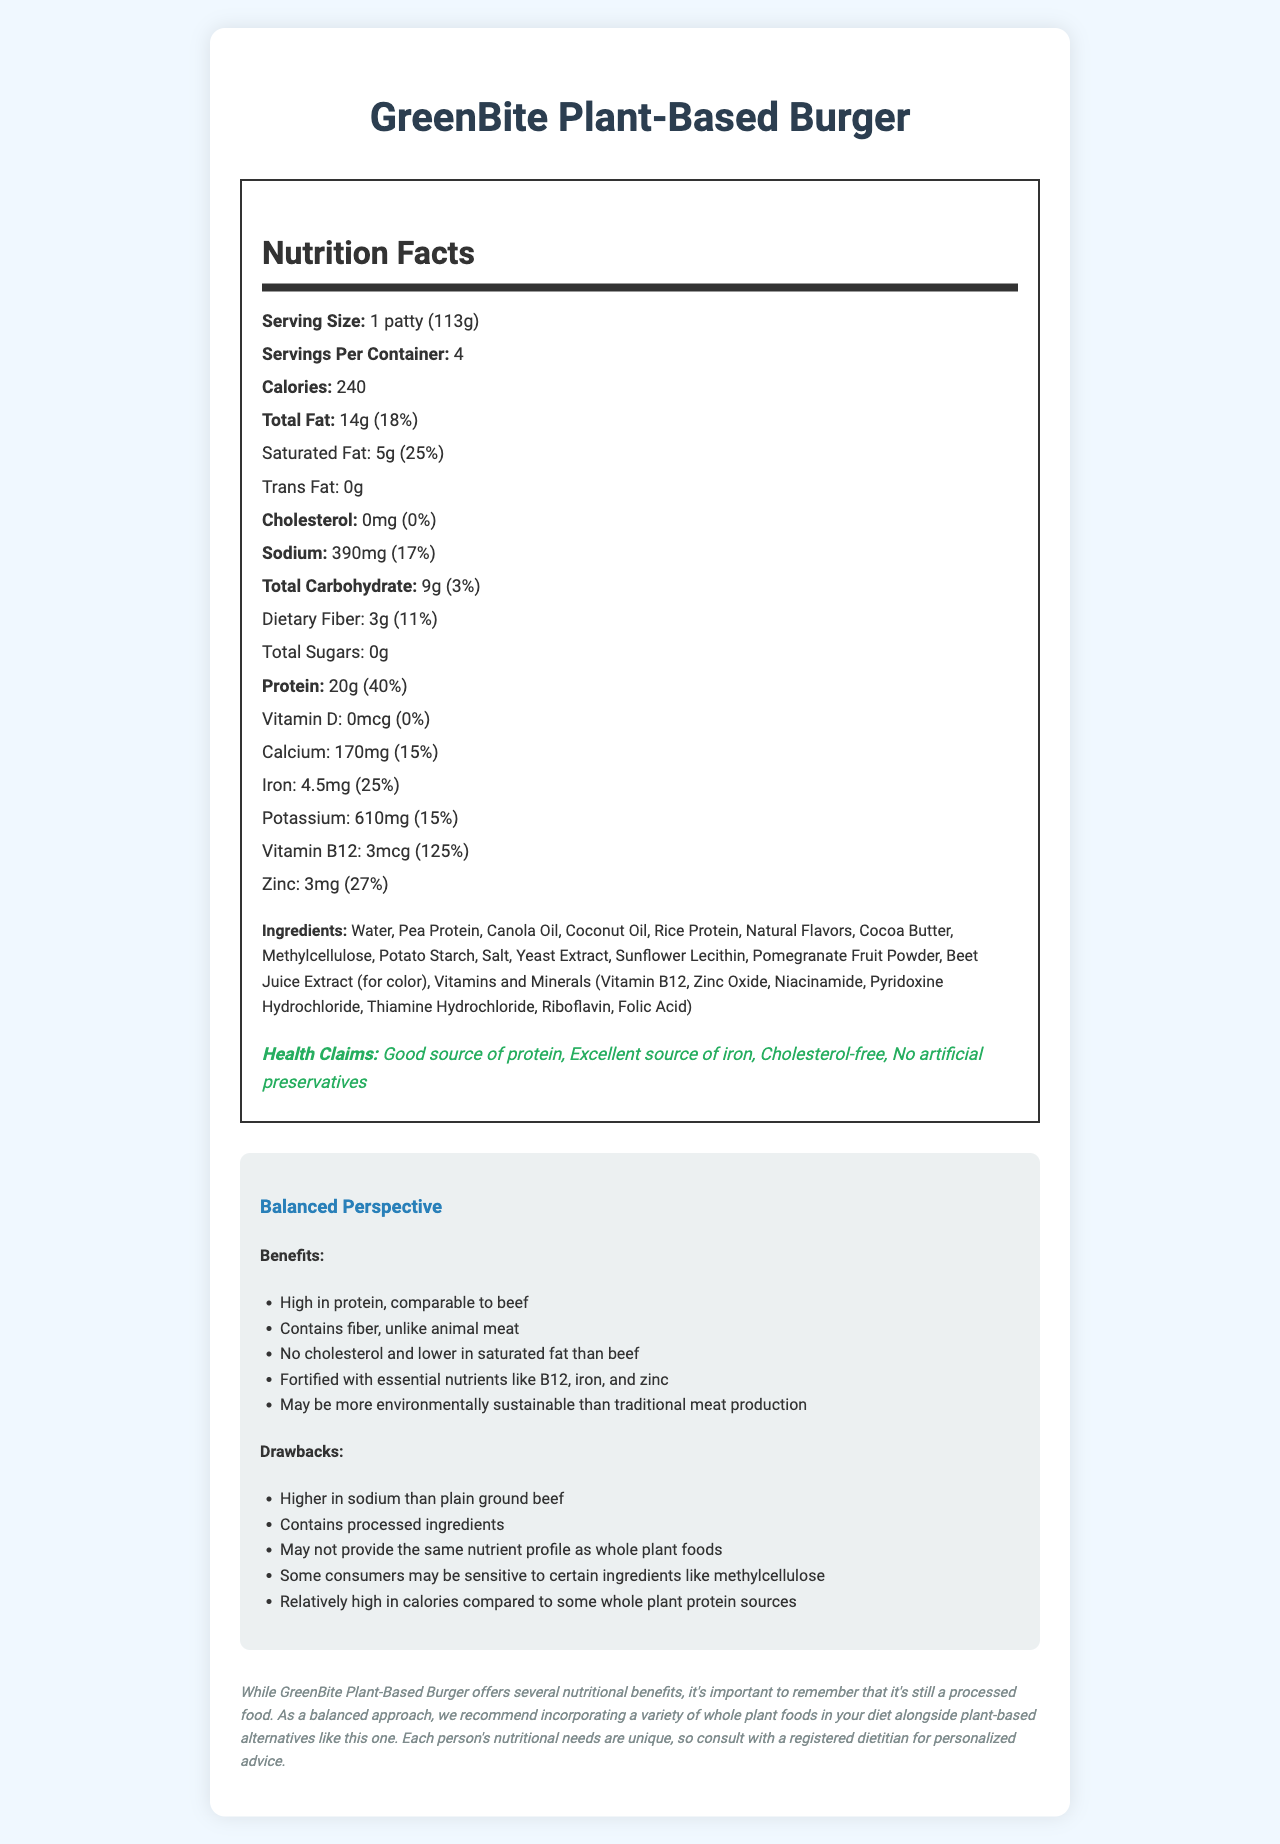what is the serving size for GreenBite Plant-Based Burger? The serving size is listed right below the product name and is specified as "1 patty (113g)."
Answer: 1 patty (113g) how many servings are there per container? The document indicates that there are 4 servings per container.
Answer: 4 how many grams of saturated fat are in one serving? Saturated fat is specified to be 5g per serving, found under the total fat section.
Answer: 5g what is the daily value percentage for protein per serving? The document states that one serving has 40% of the daily value for protein.
Answer: 40% does the GreenBite Plant-Based Burger contain any cholesterol? The cholesterol section indicates that there is 0mg of cholesterol per serving, which is 0% of the daily value.
Answer: No which nutrient has the highest daily value percentage: vitamin D, calcium, iron, or vitamin B12? A. Vitamin D B. Calcium C. Iron D. Vitamin B12 Vitamin B12 has 125% of the daily value per serving, whereas vitamin D has 0%, calcium has 15%, and iron has 25%.
Answer: D. Vitamin B12 is the GreenBite Plant-Based Burger free from artificial preservatives? One of the health claims explicitly states that the product contains no artificial preservatives.
Answer: Yes which ingredient is used for color in the GreenBite Plant-Based Burger? A. Pomegranate Fruit Powder B. Beet Juice Extract C. Cocoa Butter D. Rice Protein The ingredients list specifies beet juice extract is used for color.
Answer: B. Beet Juice Extract describe one benefit and one drawback of this product from a balanced perspective. The document highlights several benefits and drawbacks in the balanced perspective section. One benefit mentioned is that the product is high in protein, and a drawback is that it has more sodium compared to plain ground beef.
Answer: Benefit: High in protein, comparable to beef. Drawback: Higher in sodium than plain ground beef. how much calcium is in one serving of this burger? The nutrition facts section lists 170mg of calcium per serving.
Answer: 170mg does this product contain any allergens? The allergens section states that the product contains coconut.
Answer: Yes, it contains coconut. what ingredient may be a concern for those sensitive to processed foods? The balanced perspective section mentions that some consumers may be sensitive to methylcellulose, which is a processed ingredient.
Answer: Methylcellulose what are the main health claims made by this product? The health claims section mentions these specific claims made by the product.
Answer: Good source of protein, excellent source of iron, cholesterol-free, no artificial preservatives is this product higher in calories compared to some whole plant protein sources? The balanced perspective section indicates that the GreenBite Plant-Based Burger is relatively high in calories compared to some whole plant protein sources.
Answer: Yes what is the suggested dietary approach mentioned in the additional notes? The additional notes recommend a balanced approach that includes a variety of whole plant foods in your diet along with plant-based alternatives.
Answer: Incorporate a variety of whole plant foods alongside plant-based alternatives. how does this document suggest the GreenBite Plant-Based Burger compares environmentally to traditional meat production? The benefits section mentions that the product may be more environmentally sustainable than traditional meat production.
Answer: It may be more environmentally sustainable. what information does the document provide about potential product sensitivity for some consumers? The drawbacks section of the balanced perspective mentions potential sensitivity to methylcellulose.
Answer: Some consumers may be sensitive to ingredients like methylcellulose. can this burger provide the same nutrient profile as whole plant foods? The drawbacks section states that the burger may not provide the same nutrient profile as whole plant foods.
Answer: No what is one nutrient that the GreenBite Plant-Based Burger is fortified with? The ingredients list includes vitamin B12 among the vitamins and minerals the product is fortified with.
Answer: Vitamin B12 what is the main idea of the document? The document aims to give a comprehensive view of the GreenBite Plant-Based Burger, including its nutritional content, ingredients, health claims, benefits, and potential drawbacks, suggesting a balanced dietary approach.
Answer: The document provides detailed nutritional information, lists ingredients and allergens, highlights health claims, discusses benefits and drawbacks, and recommends a balanced dietary approach involving whole plant foods. what is the protein content per serving compared to the daily value percentage? The nutrition facts section reveals that one serving has 20g of protein, equating to 40% of the daily value.
Answer: 20g, which is 40% of the daily value is it clear from the document whether the GreenBite Plant-Based Burger is gluten-free? The document does not provide any information about gluten content or whether the product is gluten-free.
Answer: Not enough information 